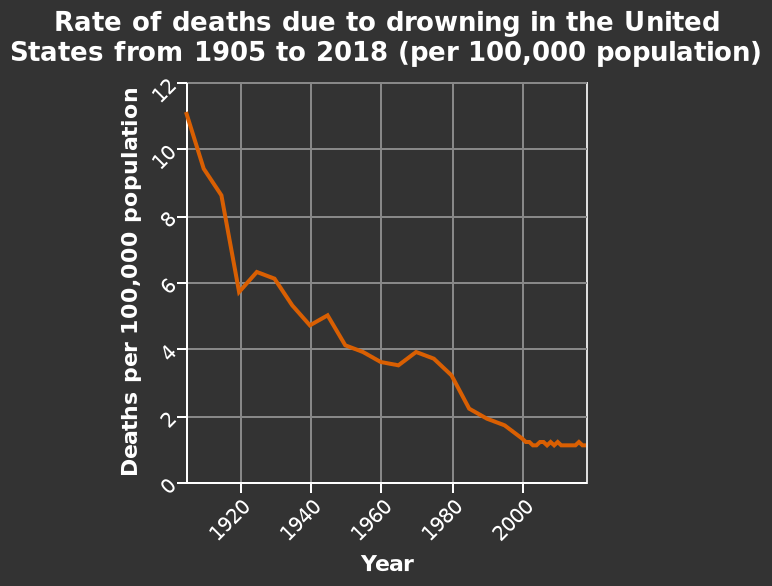<image>
What factors have contributed to the decline in drowning deaths? Various factors such as improved swimming techniques, better safety measures, and increased awareness have contributed to the decline in drowning deaths. Describe the following image in detail Here a line diagram is labeled Rate of deaths due to drowning in the United States from 1905 to 2018 (per 100,000 population). The x-axis measures Year while the y-axis measures Deaths per 100,000 population. What is being measured on the y-axis using the line diagram? On the y-axis, the line diagram measures Deaths per 100,000 population. How has swimming improved since the 1920's?  Swimming has greatly improved since the 1920's, particularly in terms of safety and reducing drowning deaths. What is the significance of the decline in drowning deaths? The decline in drowning deaths is huge, indicating that measures taken to promote swimming safety have been successful. 